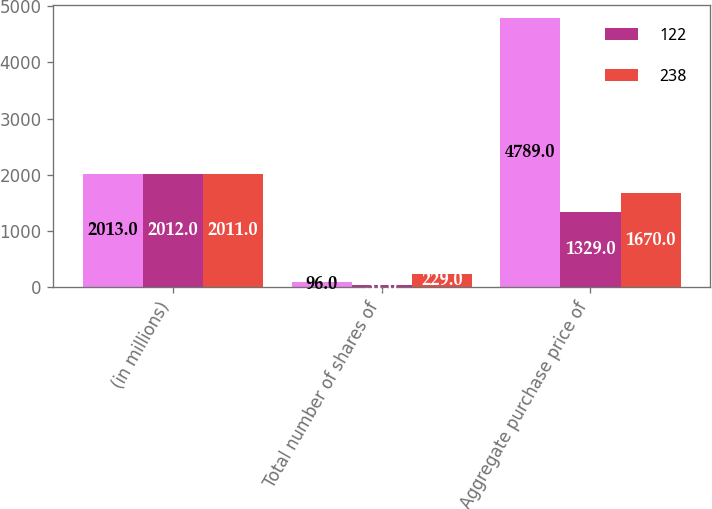Convert chart to OTSL. <chart><loc_0><loc_0><loc_500><loc_500><stacked_bar_chart><ecel><fcel>(in millions)<fcel>Total number of shares of<fcel>Aggregate purchase price of<nl><fcel>nan<fcel>2013<fcel>96<fcel>4789<nl><fcel>122<fcel>2012<fcel>31<fcel>1329<nl><fcel>238<fcel>2011<fcel>229<fcel>1670<nl></chart> 